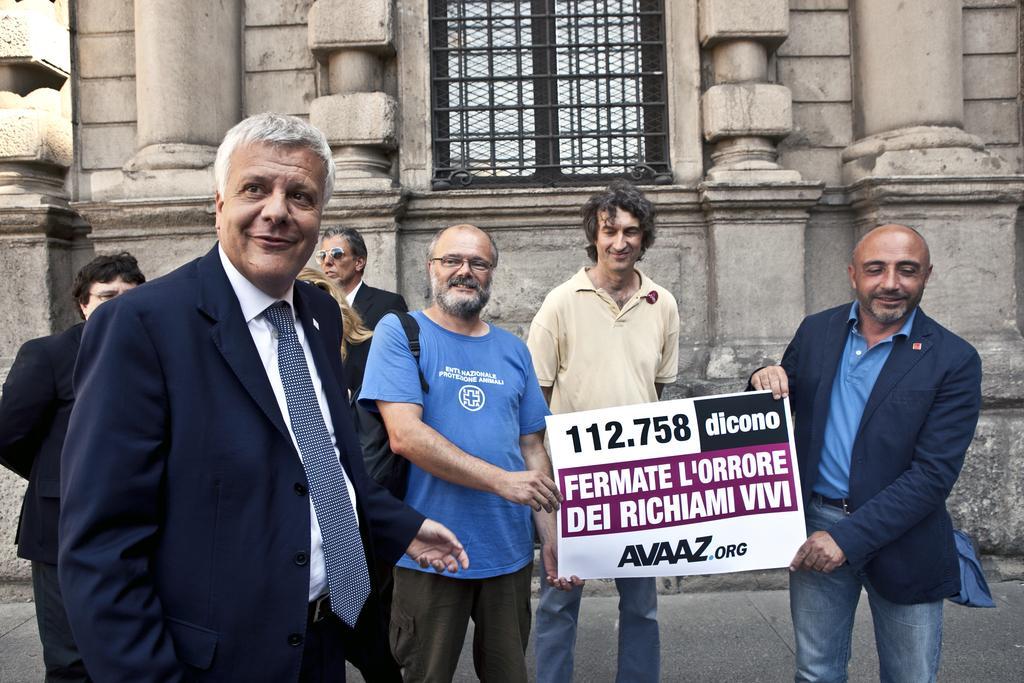Can you describe this image briefly? In the center of the image there are people holding a poster. In the background of the image there is a building. There is a window. At the bottom of the image there is road. 